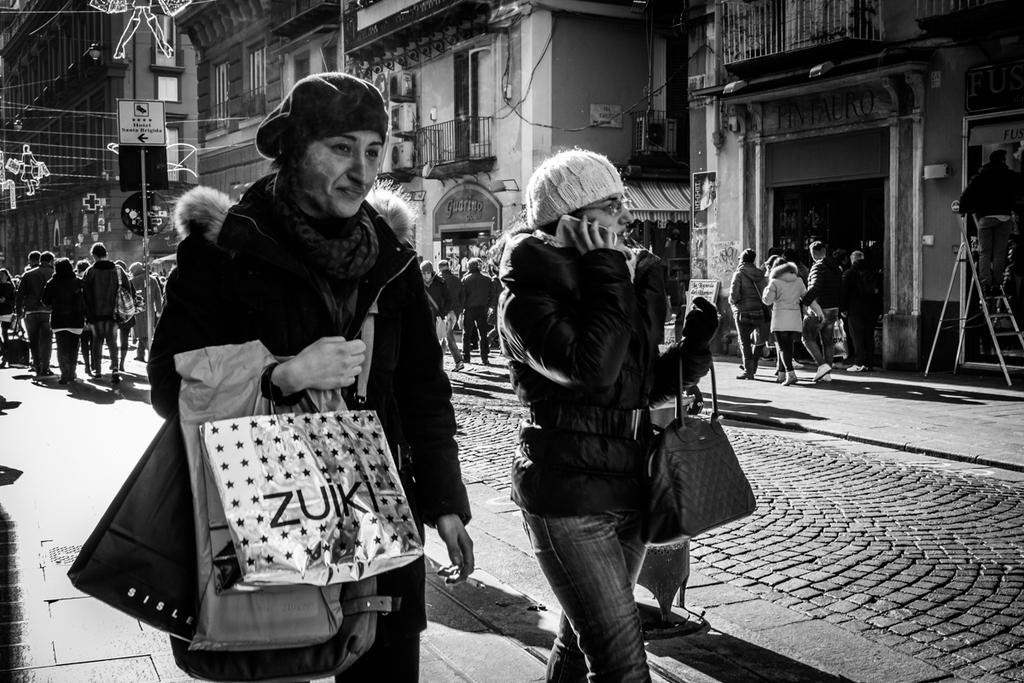What is the color scheme of the image? The image is black and white. Who or what can be seen in the image? There are people and buildings in the image. What objects are present in the image? There are boards and a ladder in the image. Can you describe the unspecified "things" in the image? Unfortunately, the provided facts do not specify what these "things" are. How are the two people in the front of the image dressed? The two people in the front of the image are wearing bags, jackets, and caps. Are the people in the image celebrating a holiday? There is no indication in the image that the people are celebrating a holiday. Can you tell me if there is a judge present in the image? There is no mention of a judge or any judicial setting in the provided facts, so it cannot be determined from the image. 